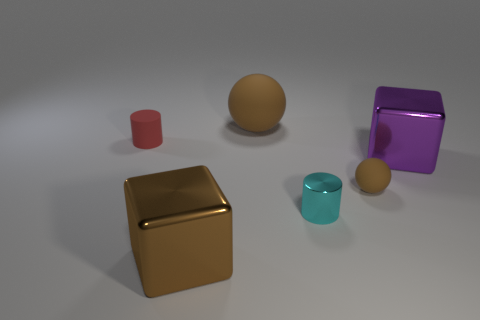Add 3 brown matte spheres. How many objects exist? 9 Subtract all balls. How many objects are left? 4 Add 1 large brown metallic cubes. How many large brown metallic cubes exist? 2 Subtract 0 cyan cubes. How many objects are left? 6 Subtract all large yellow matte cubes. Subtract all red objects. How many objects are left? 5 Add 1 red rubber things. How many red rubber things are left? 2 